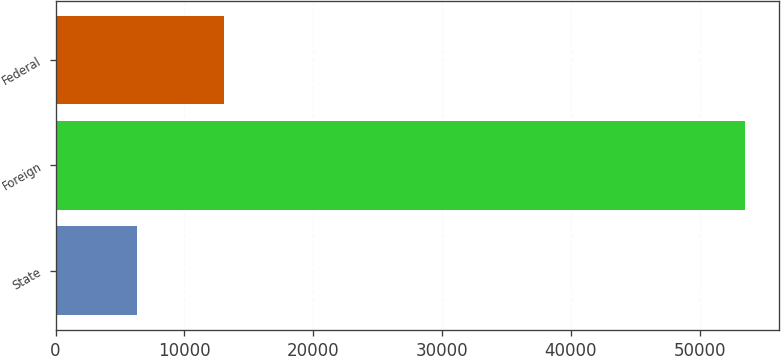<chart> <loc_0><loc_0><loc_500><loc_500><bar_chart><fcel>State<fcel>Foreign<fcel>Federal<nl><fcel>6321<fcel>53513<fcel>13094<nl></chart> 